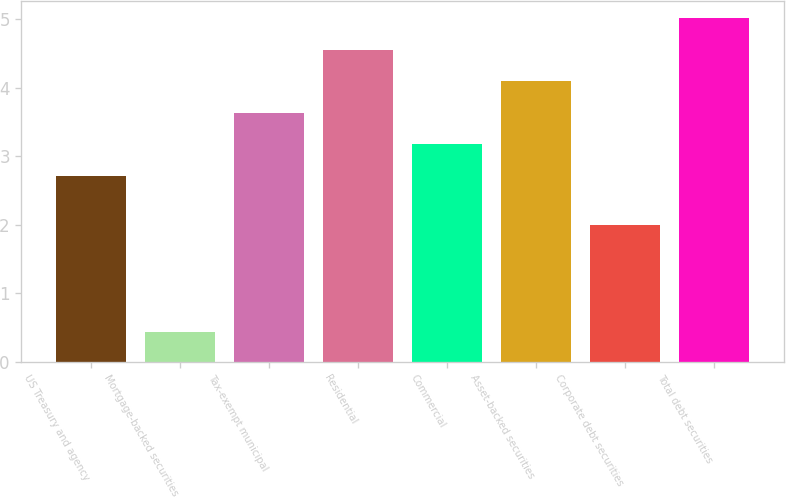<chart> <loc_0><loc_0><loc_500><loc_500><bar_chart><fcel>US Treasury and agency<fcel>Mortgage-backed securities<fcel>Tax-exempt municipal<fcel>Residential<fcel>Commercial<fcel>Asset-backed securities<fcel>Corporate debt securities<fcel>Total debt securities<nl><fcel>2.72<fcel>0.44<fcel>3.64<fcel>4.56<fcel>3.18<fcel>4.1<fcel>2<fcel>5.02<nl></chart> 